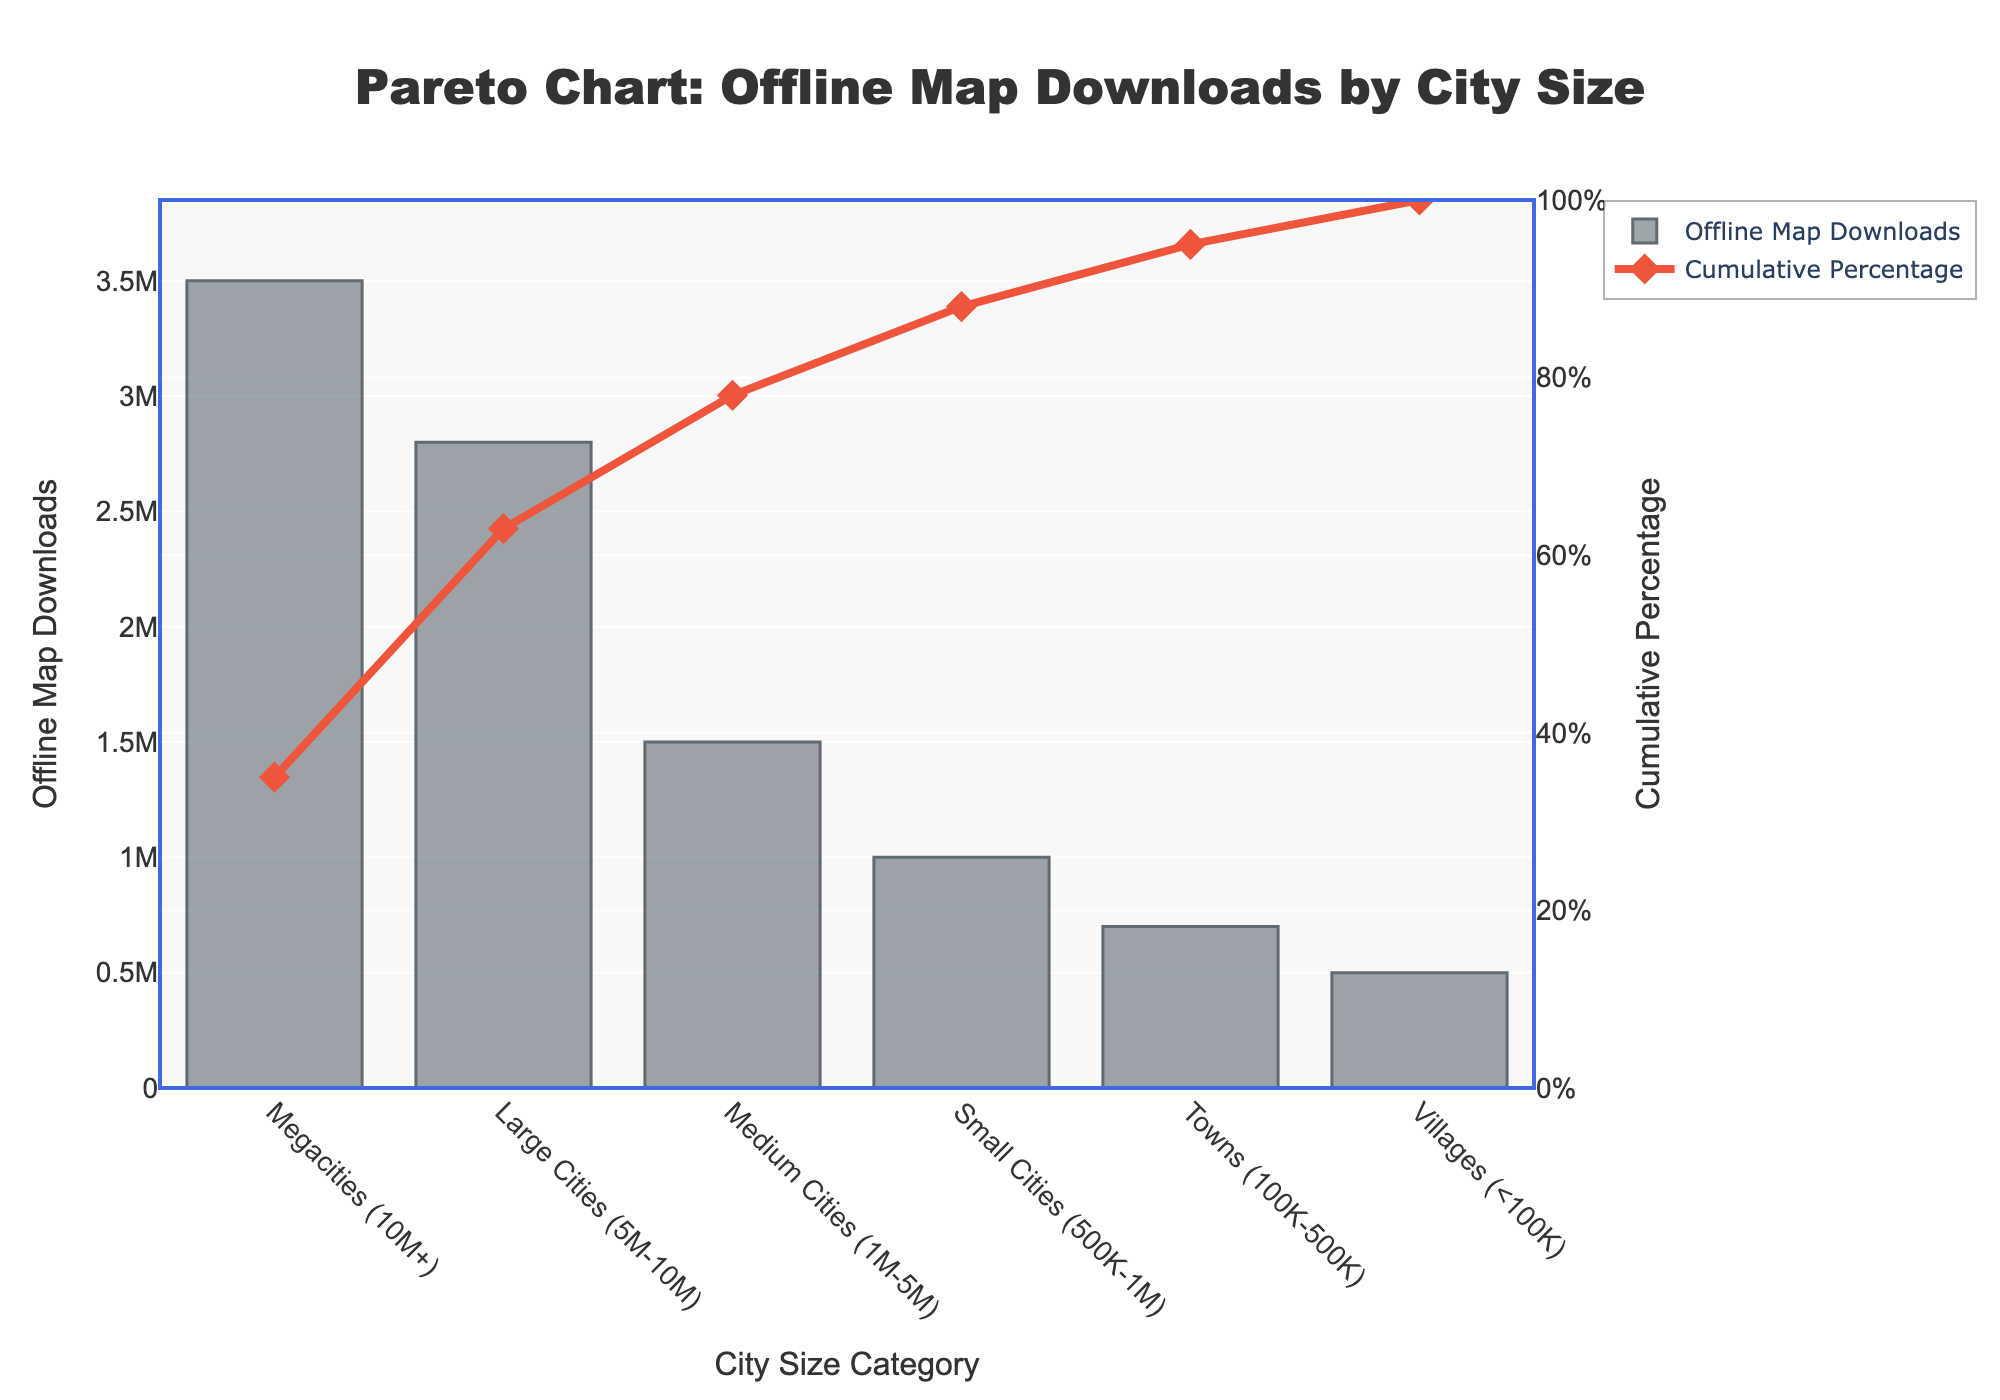What is the title of the chart? The title of the chart is located at the top and reads 'Pareto Chart: Offline Map Downloads by City Size'.
Answer: Pareto Chart: Offline Map Downloads by City Size Which city size category has the highest number of offline map downloads? By observing the height of the bars, the Megacities (10M+) category has the highest number of offline map downloads.
Answer: Megacities (10M+) What is the cumulative percentage for Large Cities? Referring to the line chart overlaid on the bar chart, Large Cities (5M-10M) have a cumulative percentage of 63%.
Answer: 63% How many downloads are represented by the Small Cities category? By looking at the bar corresponding to Small Cities (500K-1M), it shows 1,000,000 offline map downloads.
Answer: 1,000,000 What is the difference in offline map downloads between Medium Cities and Villages? The offline map downloads for Medium Cities (1M-5M) is 1,500,000, and for Villages (<100K) it is 500,000. The difference is found by subtraction: 1,500,000 - 500,000 = 1,000,000.
Answer: 1,000,000 Which city size category contributes to the cumulative percentage reaching 100%? Observing the line chart component of the Pareto chart, Villages (<100K) are the final category, bringing the cumulative percentage to 100%.
Answer: Villages (<100K) Are there any city size categories with equal offline map downloads? Each bar representing a city size category varies, indicating there are no categories with equal number of offline map downloads.
Answer: No How many data points are plotted on the chart? By counting the discrete bars representing each category, there are 6 data points.
Answer: 6 Which city size category is responsible for pushing the cumulative percentage above 75%? Looking at the cumulative percentage line, the category that brings the cumulative percentage from 63% to 78% is Medium Cities (1M-5M).
Answer: Medium Cities (1M-5M) 